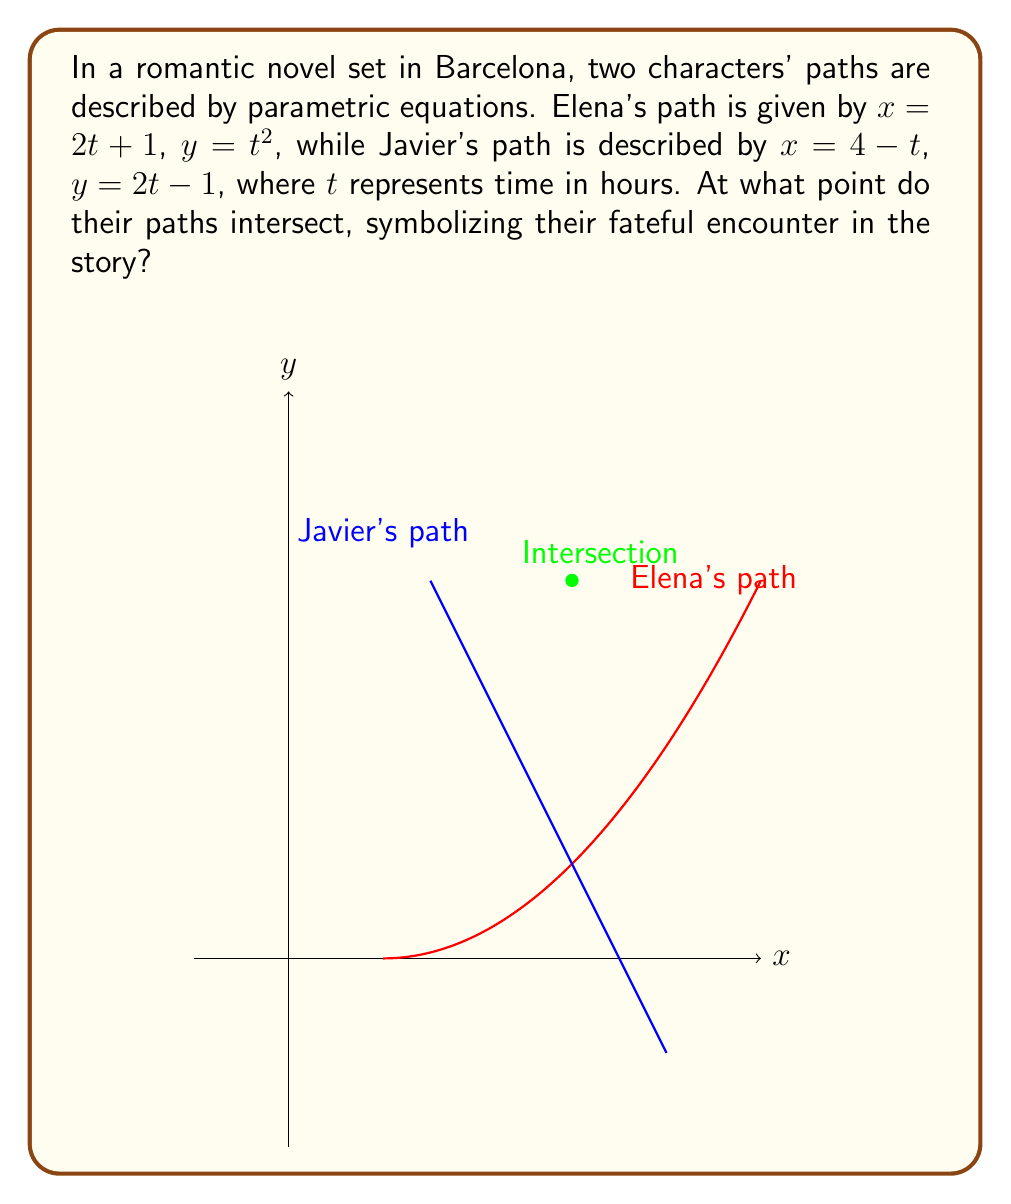Solve this math problem. To find the intersection point, we need to solve the system of equations:

1) First, we equate the x-coordinates:
   $2t + 1 = 4 - t$
   $3t = 3$
   $t = 1$

2) Now we know that Elena's time parameter is $t_E = 1$, and Javier's is $t_J = 1$ as well.

3) Let's calculate the x-coordinate of the intersection:
   For Elena: $x = 2(1) + 1 = 3$
   For Javier: $x = 4 - 1 = 3$
   They match, confirming our solution.

4) Now let's calculate the y-coordinate:
   For Elena: $y = 1^2 = 1$
   For Javier: $y = 2(1) - 1 = 1$

5) Therefore, the intersection point is (3, 1).

6) To double-check, we can substitute these values back into both equations:
   Elena: $3 = 2(1) + 1$ and $1 = 1^2$
   Javier: $3 = 4 - 1$ and $1 = 2(1) - 1$
   Both equations are satisfied.
Answer: (3, 1) 